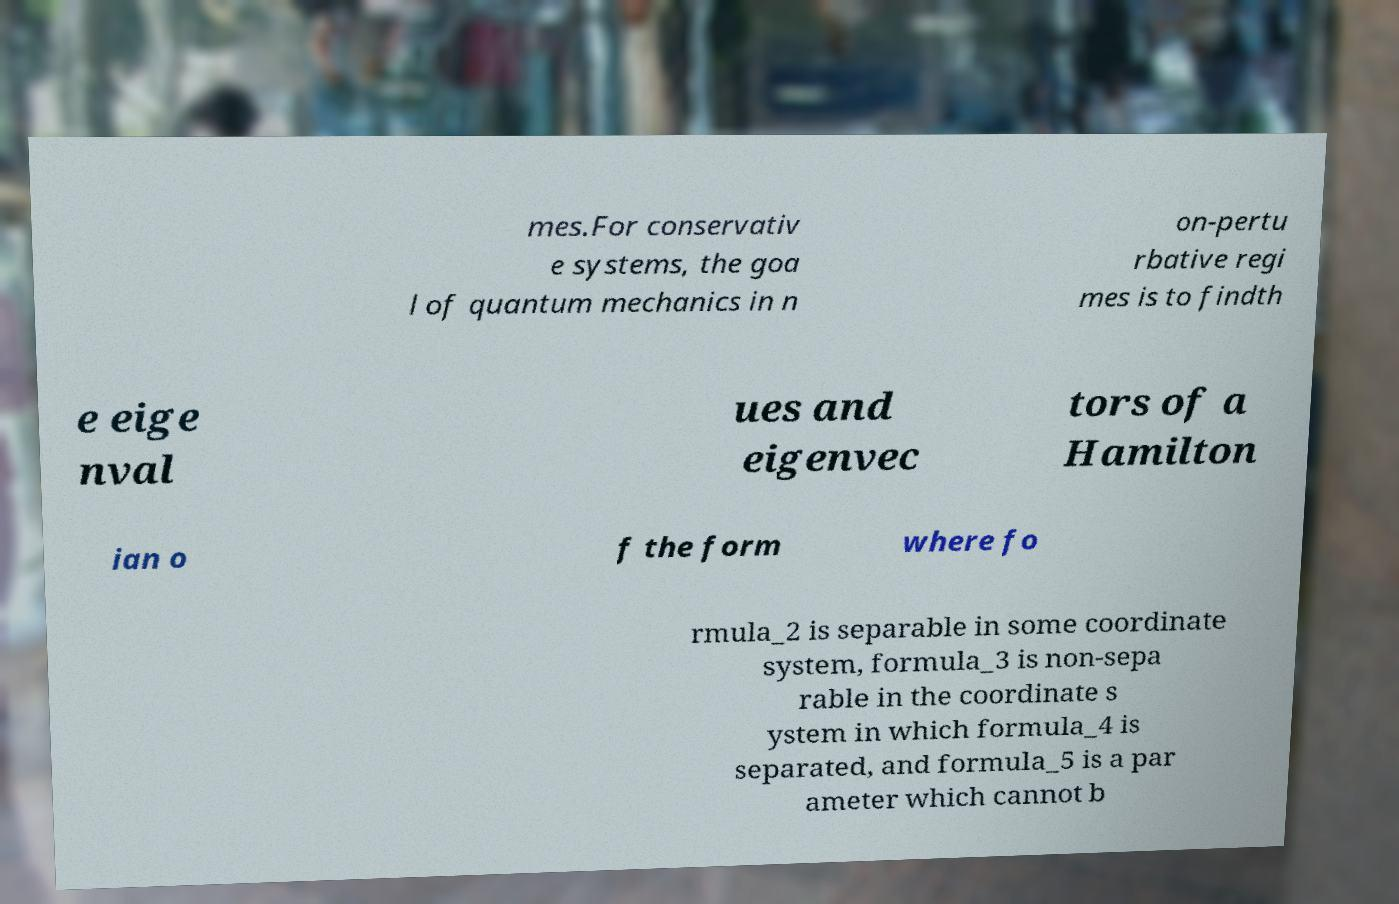I need the written content from this picture converted into text. Can you do that? mes.For conservativ e systems, the goa l of quantum mechanics in n on-pertu rbative regi mes is to findth e eige nval ues and eigenvec tors of a Hamilton ian o f the form where fo rmula_2 is separable in some coordinate system, formula_3 is non-sepa rable in the coordinate s ystem in which formula_4 is separated, and formula_5 is a par ameter which cannot b 